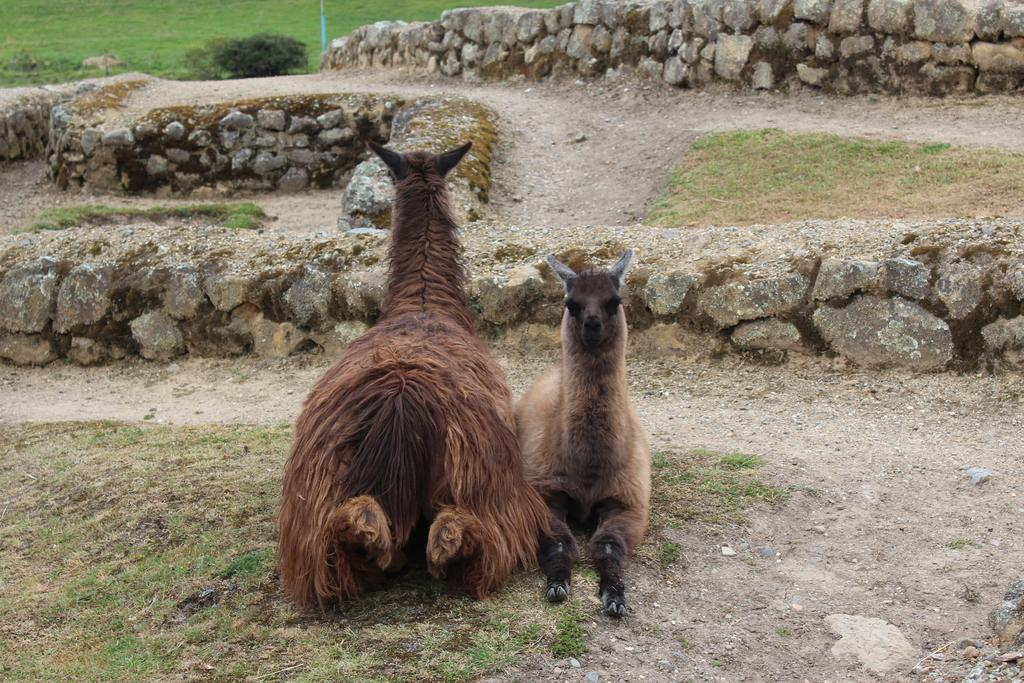What type of living organisms can be seen in the image? There are animals in the image. What is the position of the animals in the image? The animals are seated on the ground. What type of vegetation is present in the image? There is a plant and grass in the image. What other natural elements can be seen in the image? There are rocks in the image. What type of crime is being committed in the image? There is no crime being committed in the image; it features animals seated on the ground with plants and rocks nearby. What is the distance between the animals and the plant in the image? The distance between the animals and the plant cannot be determined from the image, as there is no reference point or scale provided. 